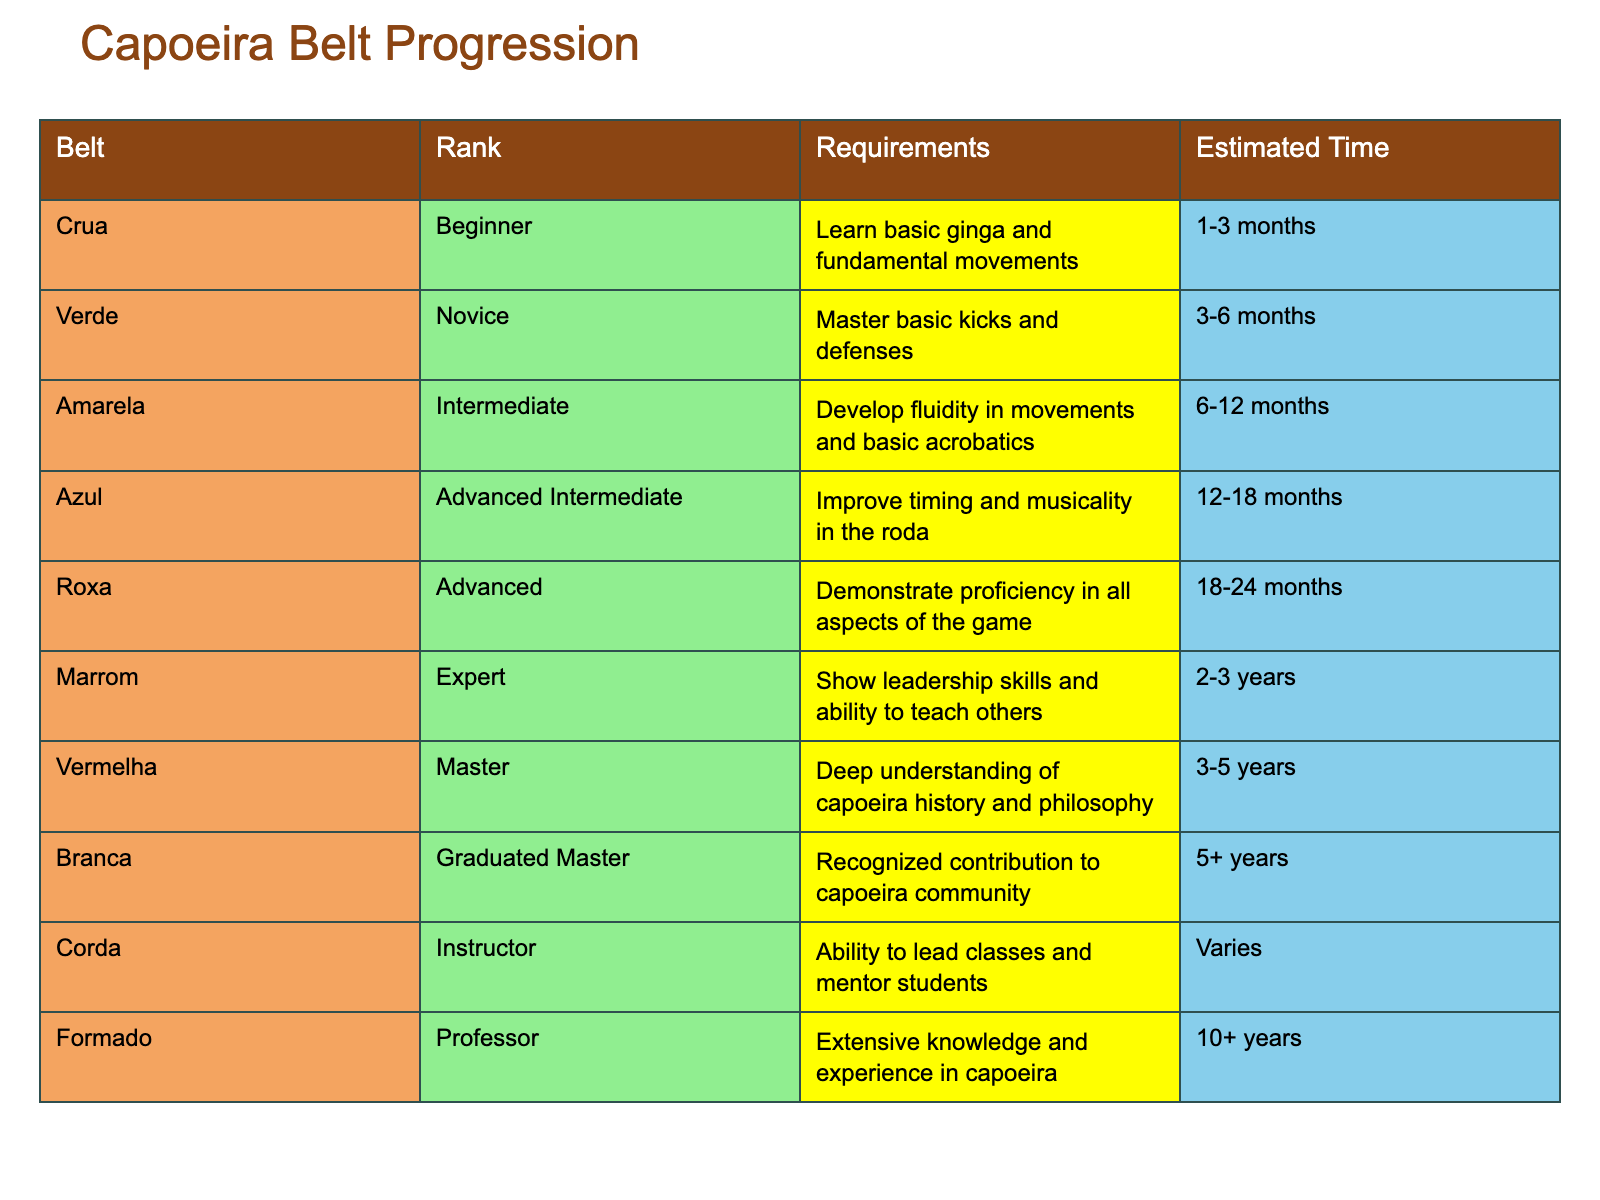What is the requirement for the Amarela belt? The table indicates that the requirement for the Amarela belt is to develop fluidity in movements and basic acrobatics.
Answer: Develop fluidity in movements and basic acrobatics How long does it typically take to achieve the Azul belt? According to the table, the estimated time to achieve the Azul belt is 12 to 18 months.
Answer: 12 to 18 months Is the Marrom belt considered an Expert rank? The table clearly states that the Marrom belt is classified as an Expert rank. Therefore, the statement is true.
Answer: Yes What is the difference in estimated time between the Marrom and Vermelha belts? The estimated time for the Marrom belt is 2 to 3 years, and for the Vermelha belt, it is 3 to 5 years. To find the difference, we consider the minimums (2 to 3 years) and maximums (3 to 5 years), giving a range of 1 to 2 years difference.
Answer: 1 to 2 years What is the total estimated time to progress from Crua to Vermelha? The times needed for each belt are: 1-3 months for Crua, 3-6 months for Verde, 6-12 months for Amarela, 12-18 months for Azul, 18-24 months for Roxa, and 3-5 years (or 36-60 months) for Vermelha. Converting all to months: 1-3 + 3-6 + 6-12 + 12-18 + 18-24 + 36-60 gives: 1 + 3 + 6 + 12 + 18 + 36 = 76 months (min) and 3 + 6 + 12 + 18 + 24 + 60 = 123 months (max). Therefore, the total range is 76 to 123 months.
Answer: 76 to 123 months What rank comes after the Azul belt in the progression? The table indicates that the rank following the Azul belt is the Roxa belt.
Answer: Roxa How many belts are classified as "Advanced" or above? In the table, the belts classified as "Advanced" or above are Azul, Roxa, Marrom, Vermelha, Branca, Corda, and Formado. That totals 6 belts.
Answer: 6 belts Is it possible to progress to the Professor rank immediately after achieving the Marrom rank? The table does not list a direct progression from Marrom to Professor; it indicates that one must achieve the Corda or Instructor rank before reaching Professor. Therefore, the statement is false.
Answer: No 